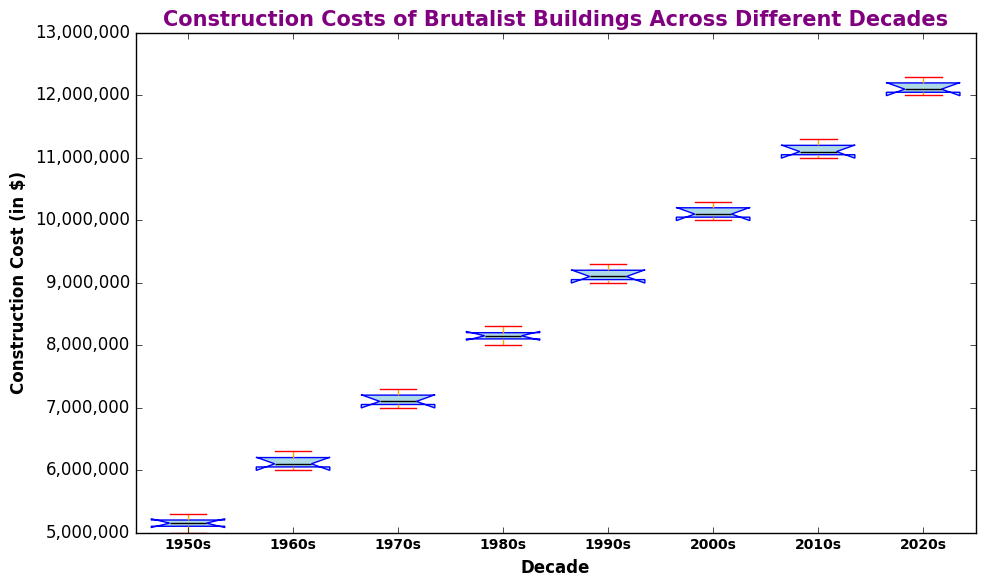What decade has the lowest median construction cost? To find which decade has the lowest median construction cost, look at the black horizontal lines inside each box that represent the median values. The 1950s box has the lowest median line.
Answer: 1950s Which decade has the highest upper whisker? The upper whiskers are the horizontal lines extending from the top of each box. The 2020s box has the highest upper whisker.
Answer: 2020s What is the interquartile range (IQR) for the 1970s? The IQR is the height of the box. For the 1970s, visually estimate the distance between the top and bottom of the box (the 75th and 25th percentiles). The IQR appears to span from approximately $7,025,000 to $7,170,000. So, the IQR is $7,170,000 - $7,025,000.
Answer: $145,000 Which decade shows the smallest range of construction costs? The range is the difference between the highest and lowest points (excluding outliers). The 1950s boxplot shows the smallest range.
Answer: 1950s Compare the medians of the 1980s and 1990s? To compare medians, look at the black lines inside the 1980s and 1990s boxes. The median for the 1980s is slightly lower than that of the 1990s.
Answer: The 1980s median is lower than the 1990s How does the interquartile range of the 2000s compare to that of the 1950s? Visually compare the heights of the boxes for the 2000s and 1950s. The 2000s box is taller, indicating a larger interquartile range compared to the 1950s.
Answer: The 2000s has a larger IQR than the 1950s Which decade has the most consistent construction costs? Consistency can be inferred from the smallest spread in the boxplot. The 1950s has the smallest spread, indicating the most consistent construction costs.
Answer: 1950s What decade has the most outliers? Outliers are represented by small circles. By counting the number of circles, determine that the 1950s has the most outliers.
Answer: 1950s How do the whiskers of the 2010s compare to those of the 2020s? Whiskers extend from the box to the smallest and largest values within 1.5 times the IQR. The upper whisker of the 2020s is higher than that of the 2010s, and the lower whiskers are roughly at the same level.
Answer: 2020s has a higher upper whisker Identify the decade with the widest box. The width of the box itself doesn't differ much due to the fixed width setting, but the height represents the interquartile range (IQR). The 2020s appears to show the highest IQR judging by the height of its box.
Answer: 2020s 